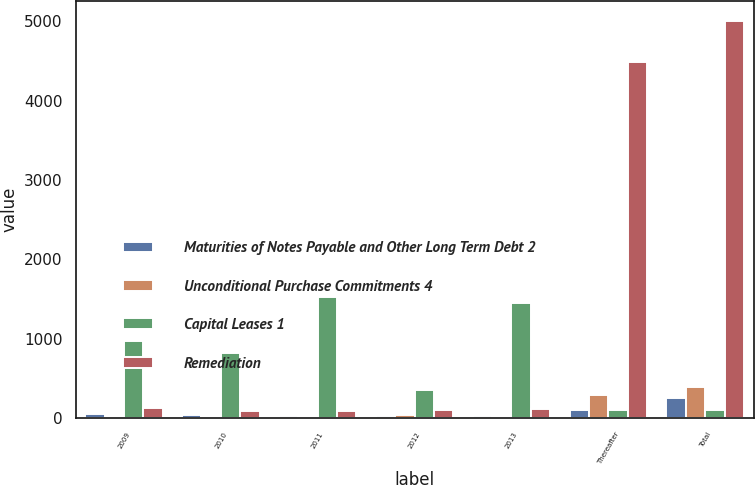Convert chart. <chart><loc_0><loc_0><loc_500><loc_500><stacked_bar_chart><ecel><fcel>2009<fcel>2010<fcel>2011<fcel>2012<fcel>2013<fcel>Thereafter<fcel>Total<nl><fcel>Maturities of Notes Payable and Other Long Term Debt 2<fcel>44.5<fcel>36<fcel>29<fcel>22.6<fcel>20.1<fcel>102.3<fcel>254.5<nl><fcel>Unconditional Purchase Commitments 4<fcel>10.3<fcel>16.2<fcel>15.3<fcel>40.4<fcel>14.7<fcel>290.2<fcel>387.1<nl><fcel>Capital Leases 1<fcel>966.6<fcel>824.6<fcel>1528<fcel>358<fcel>1453.9<fcel>103.7<fcel>103.7<nl><fcel>Remediation<fcel>130.6<fcel>86.2<fcel>87.9<fcel>105.1<fcel>107.1<fcel>4491.9<fcel>5008.8<nl></chart> 